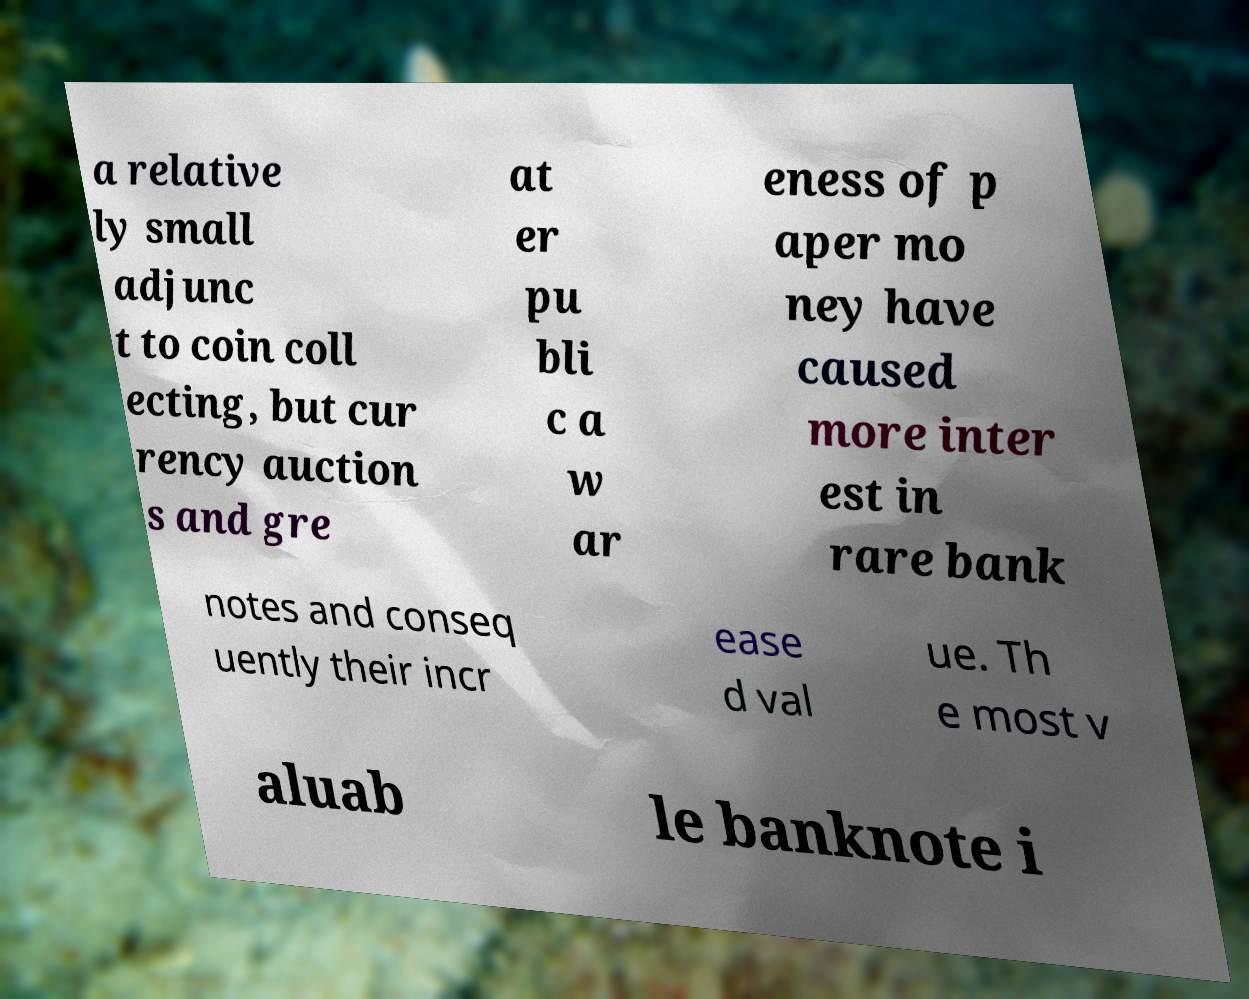Could you extract and type out the text from this image? a relative ly small adjunc t to coin coll ecting, but cur rency auction s and gre at er pu bli c a w ar eness of p aper mo ney have caused more inter est in rare bank notes and conseq uently their incr ease d val ue. Th e most v aluab le banknote i 